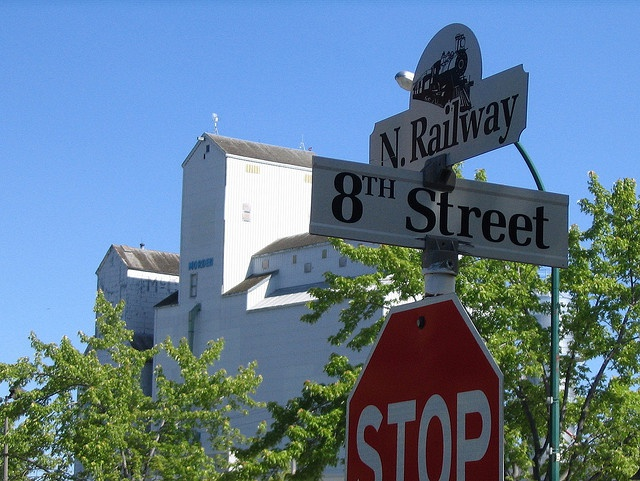Describe the objects in this image and their specific colors. I can see a stop sign in gray, maroon, and black tones in this image. 